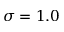<formula> <loc_0><loc_0><loc_500><loc_500>\sigma = 1 . 0</formula> 